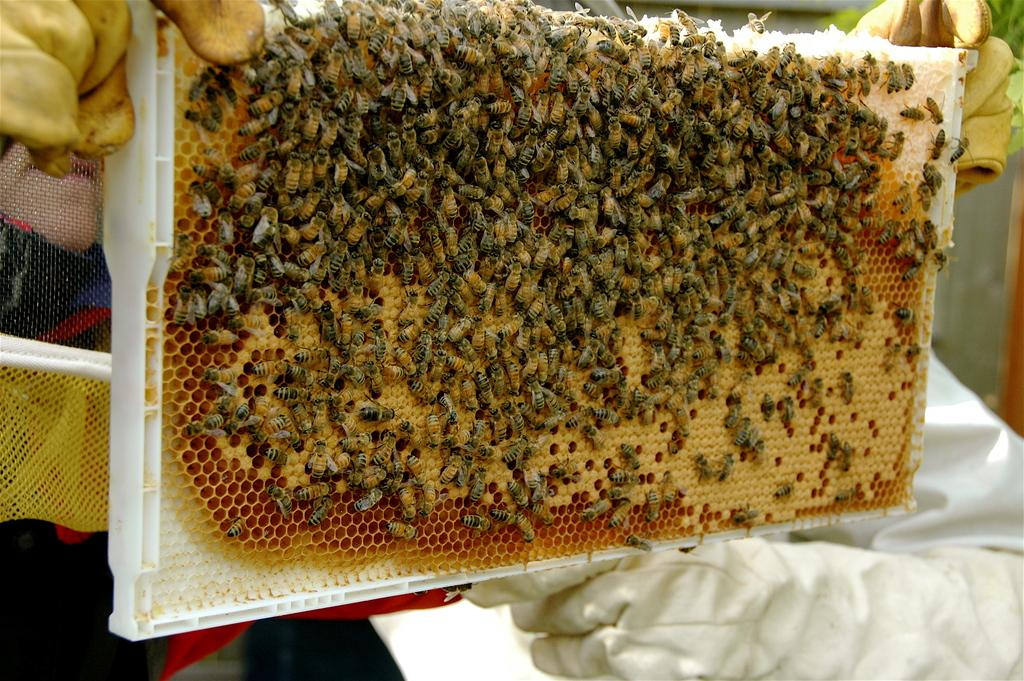What is the main subject of the picture? The main subject of the picture is a honeycomb. Are there any living organisms present on the honeycomb? Yes, there are honey bees on the honeycomb. Who is holding the honeycomb in the picture? A person is holding the honeycomb in the picture. Can you tell me how many points the honeycomb has in the image? The honeycomb does not have points; it is a hexagonal structure made up of cells. Is there a sea visible in the background of the image? There is no sea present in the image; it features a honeycomb with honey bees and a person holding it. 